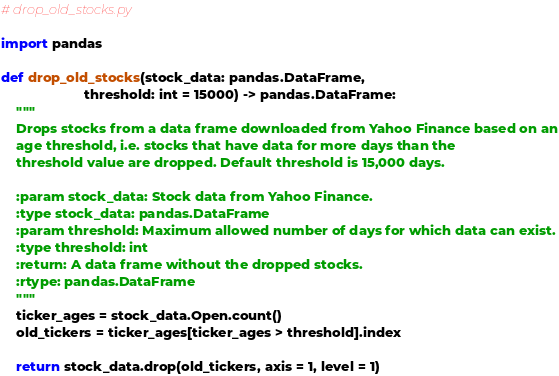Convert code to text. <code><loc_0><loc_0><loc_500><loc_500><_Python_># drop_old_stocks.py

import pandas

def drop_old_stocks(stock_data: pandas.DataFrame,
                      threshold: int = 15000) -> pandas.DataFrame:
    """
    Drops stocks from a data frame downloaded from Yahoo Finance based on an
    age threshold, i.e. stocks that have data for more days than the
    threshold value are dropped. Default threshold is 15,000 days.

    :param stock_data: Stock data from Yahoo Finance.
    :type stock_data: pandas.DataFrame
    :param threshold: Maximum allowed number of days for which data can exist.
    :type threshold: int
    :return: A data frame without the dropped stocks.
    :rtype: pandas.DataFrame
    """
    ticker_ages = stock_data.Open.count()
    old_tickers = ticker_ages[ticker_ages > threshold].index

    return stock_data.drop(old_tickers, axis = 1, level = 1)
</code> 